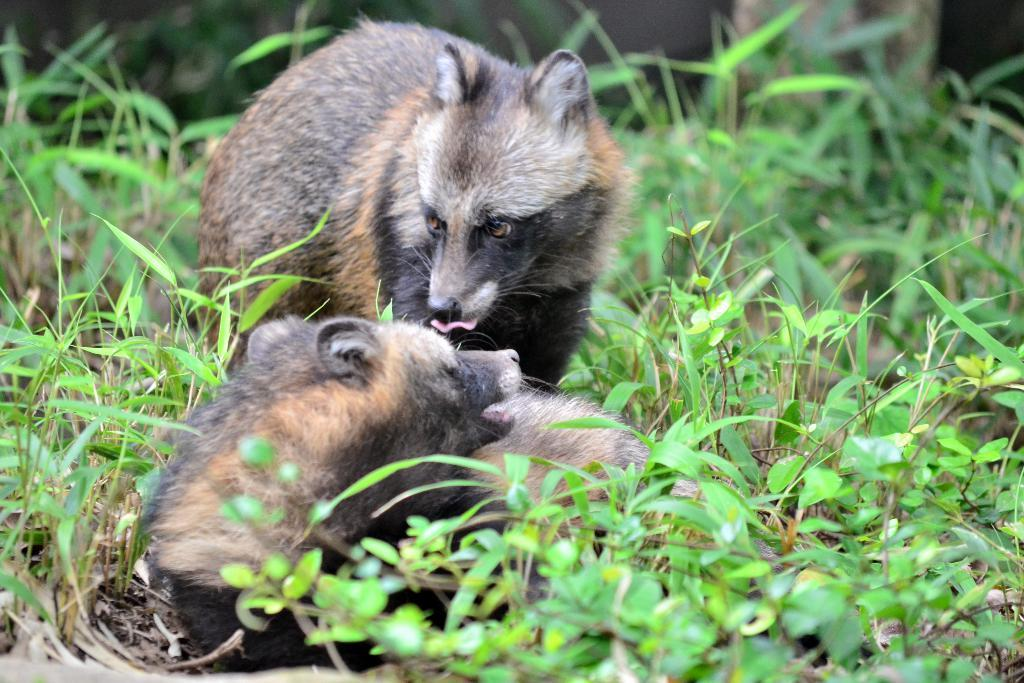How many bears are present in the image? There are two bears in the image. What are the colors of the bears? One bear is brown in color, and the other bear is black in color. What can be seen in the background of the image? There are small plants in the background of the image. What is the color of the plants? The plants are green in color. What type of tin can be seen in the image? There is no tin present in the image. Can you describe the picture hanging on the wall in the image? There is no picture hanging on the wall in the image. 